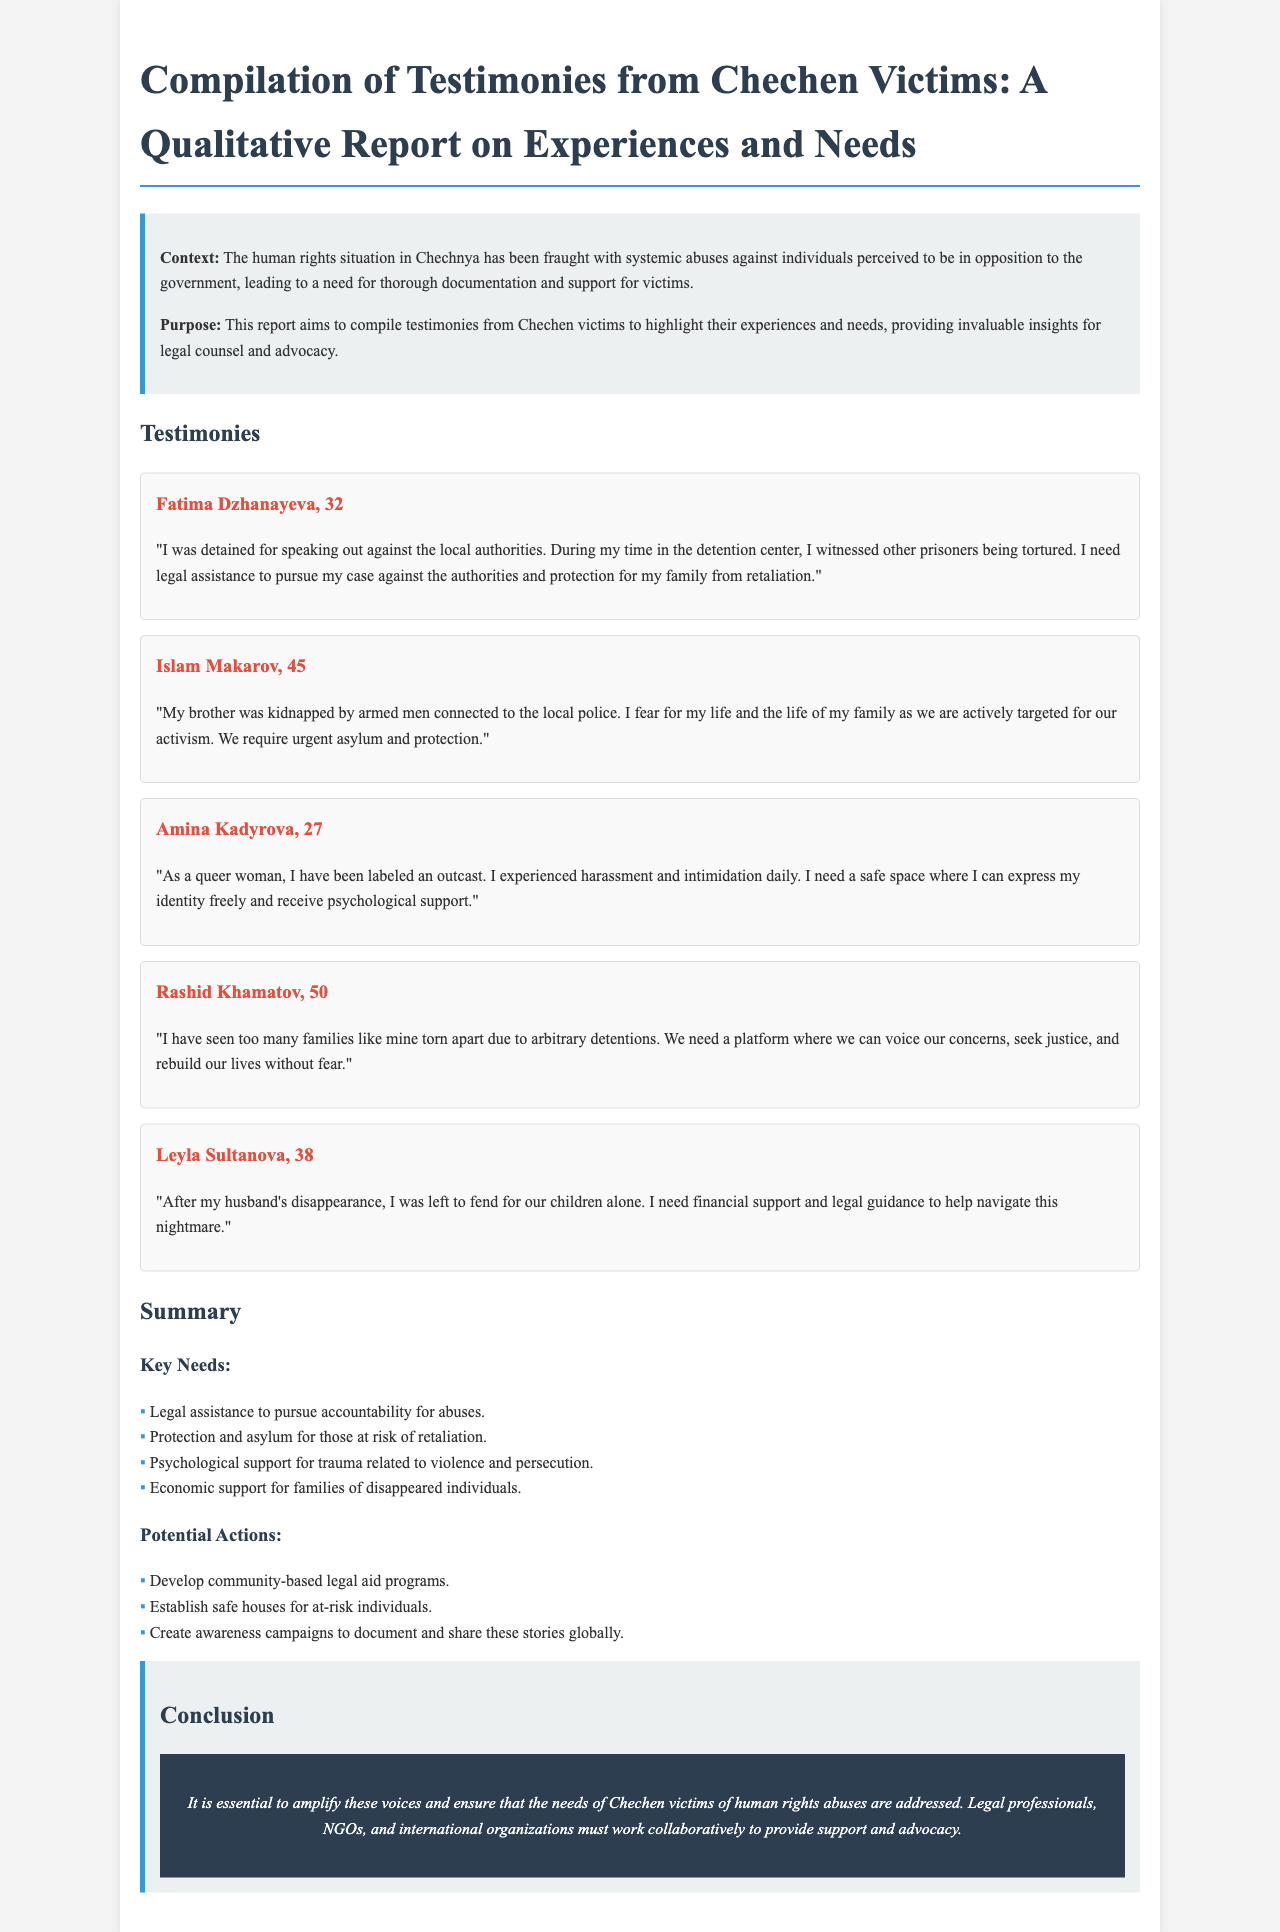What is the title of the report? The title of the report can be found at the beginning and states the focus on testimonies from Chechen victims.
Answer: Compilation of Testimonies from Chechen Victims: A Qualitative Report on Experiences and Needs Who is the first testimony from? The first testimony in the report is attributed to an individual sharing their experience of detention and torture.
Answer: Fatima Dzhanayeva What age is Amina Kadyrova? The report includes ages for each individual providing testimony, with Amina's stated age being mentioned.
Answer: 27 How many key needs are identified in the report? The report lists specific needs identified based on testimonies, and these are compiled in a bullet list format.
Answer: Four What type of support does Leyla Sultanova need? Leyla's testimony details specific needs related to her situation after her husband's disappearance, which is mentioned explicitly.
Answer: Financial support and legal guidance Which individual mentioned fear for their family's life? The testimony addressing the concern for family safety is specific to an individual's situation involving activism.
Answer: Islam Makarov What type of actions are suggested under 'Potential Actions'? The report elaborates on possible measures to be taken in response to the needs identified throughout the testimonies.
Answer: Community-based legal aid programs What is the overall context of the report? The context is provided in the introduction and outlines the general situation regarding human rights abuses in a specific region.
Answer: Systemic abuses against individuals perceived to be in opposition to the government 